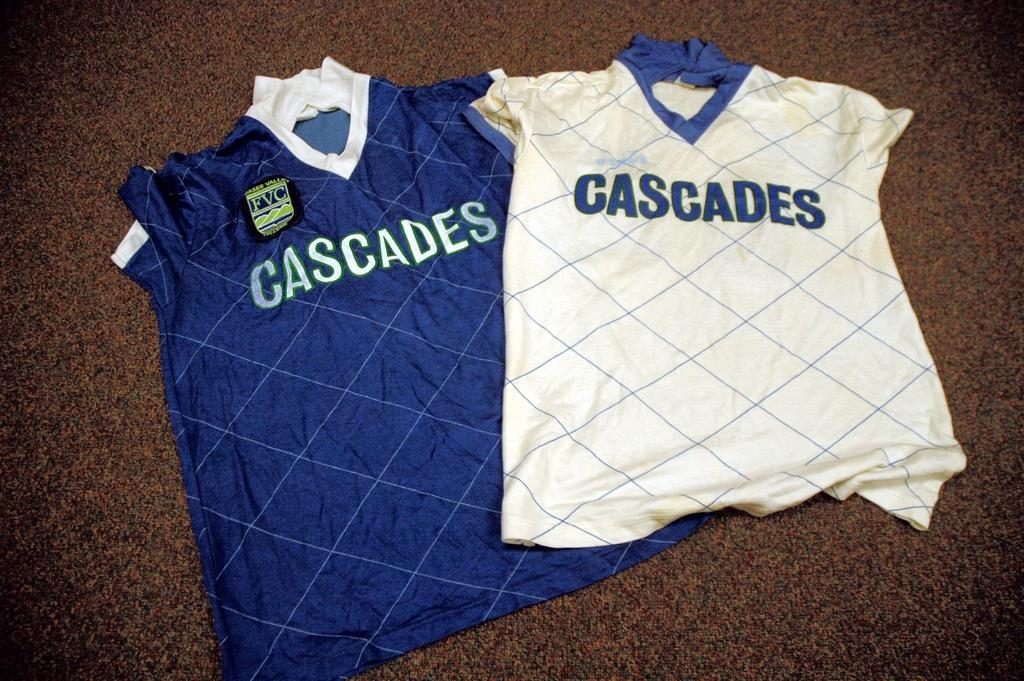What team are the jerseys for?
Keep it short and to the point. Cascades. What is the difference between these two jerseys?
Provide a succinct answer. Answering does not require reading text in the image. 